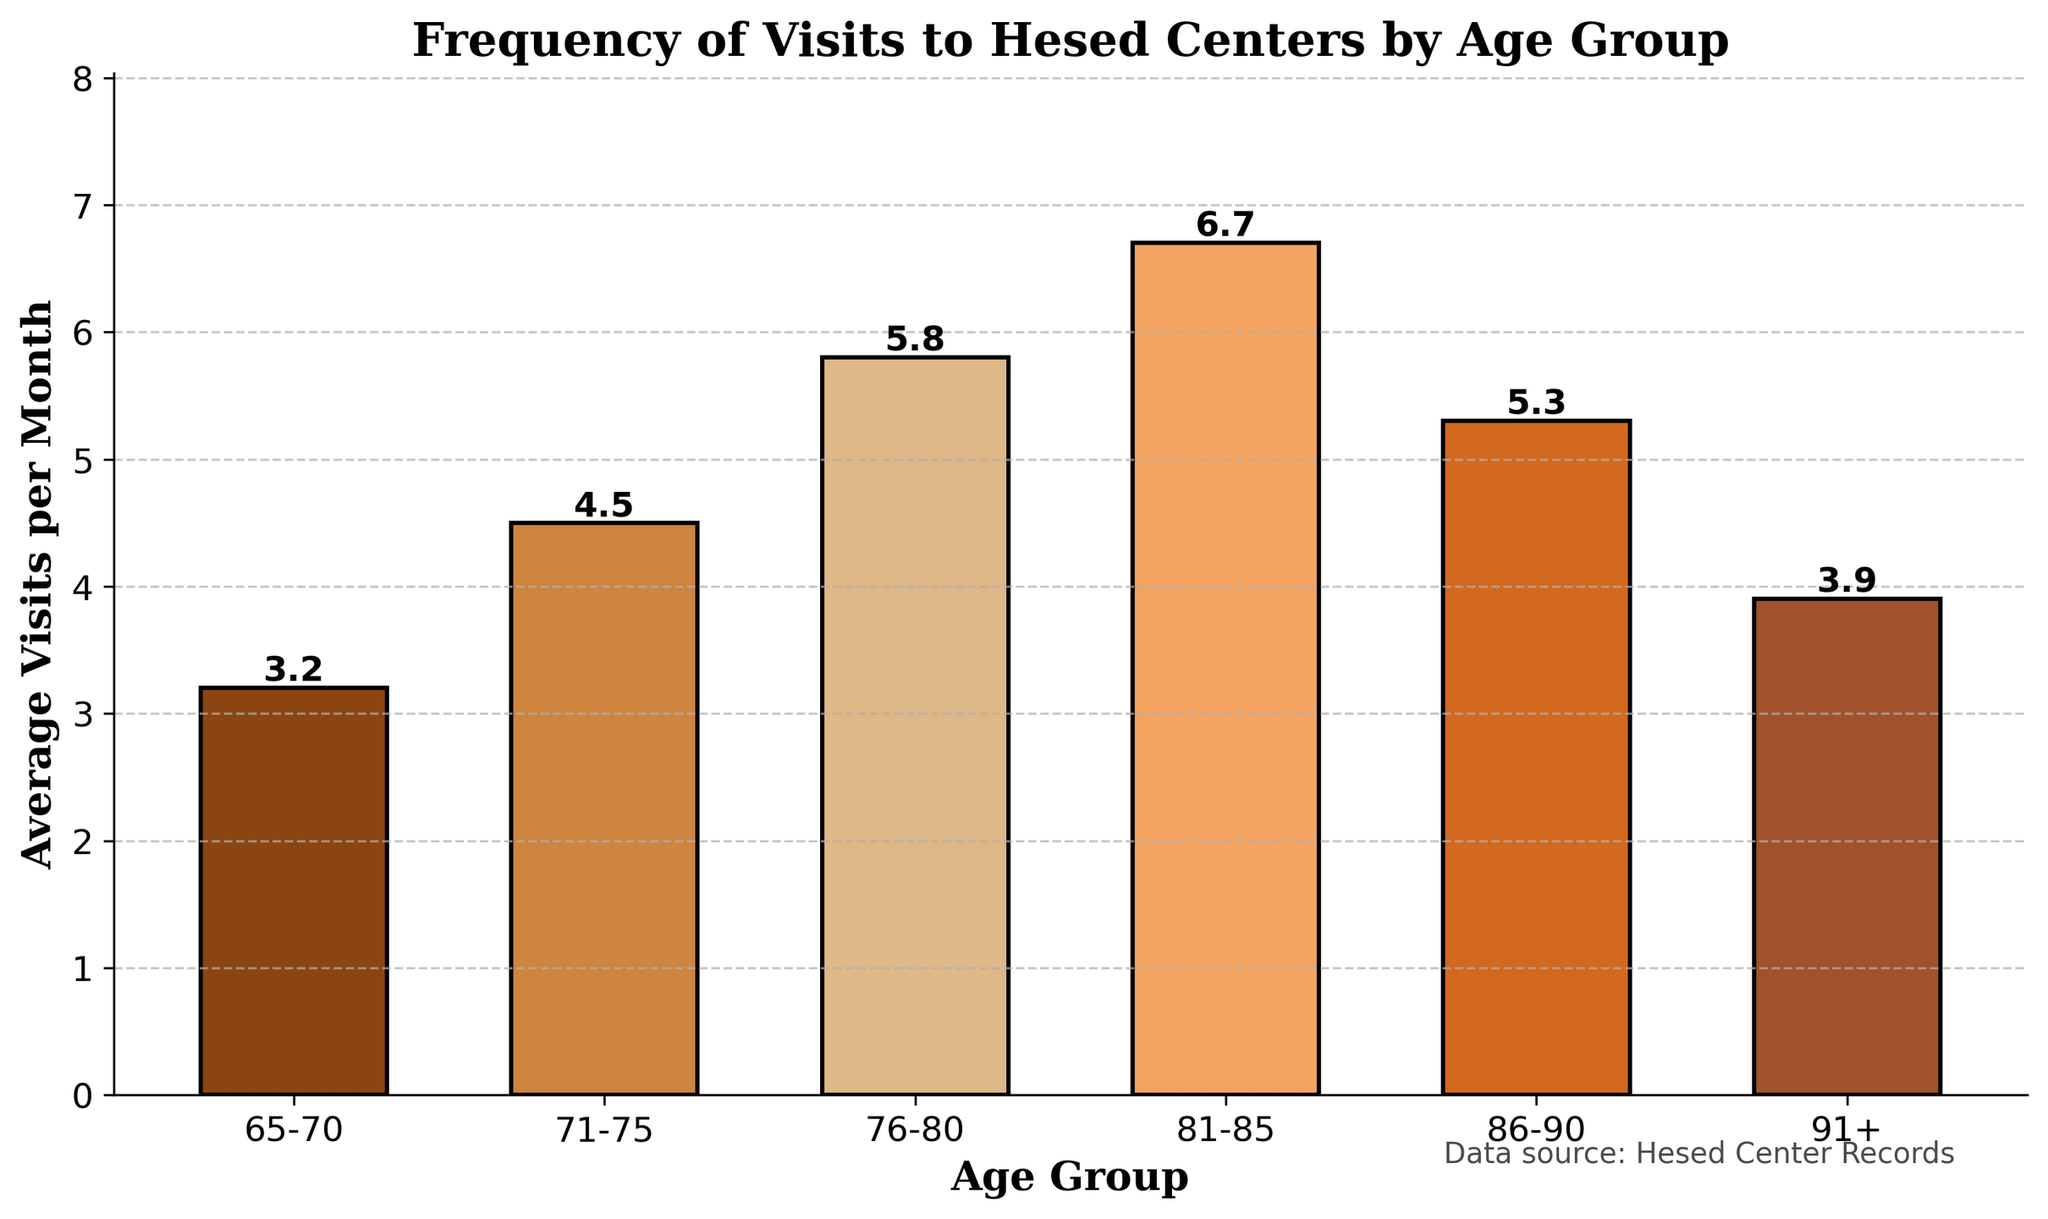What age group has the highest average visits per month? The age group with the highest bar represents the group with the most visits. By looking at the figure, the 81-85 age group has the tallest bar.
Answer: 81-85 How much is the difference in average visits per month between the 76-80 and 91+ age groups? Look at the heights of the bars for these age groups and subtract the shorter one from the taller one. The 76-80 age group has 5.8 visits, and the 91+ age group has 3.9 visits. The difference is 5.8 - 3.9.
Answer: 1.9 What is the total average visits per month for all age groups combined? Add the average visits per month of all the age groups together. The values are 3.2, 4.5, 5.8, 6.7, 5.3, and 3.9. The sum is 3.2 + 4.5 + 5.8 + 6.7 + 5.3 + 3.9.
Answer: 29.4 Which age group has a greater average visits per month: 71-75 or 86-90? Compare the heights of the bars for the 71-75 and 86-90 age groups. The 71-75 age group has 4.5 visits, while the 86-90 age group has 5.3 visits.
Answer: 86-90 What is the range of average visits per month among all age groups? The range is found by subtracting the smallest value from the largest value. The highest value is 6.7 (81-85 age group) and the lowest is 3.2 (65-70 age group). The range is 6.7 - 3.2.
Answer: 3.5 What percentage increase in average visits per month is observed from the 65-70 age group to the 81-85 age group? First, find the difference in average visits between these two groups, which is 6.7 - 3.2 = 3.5. Then calculate the percentage increase by dividing this difference by the initial number and multiplying by 100. So, (3.5 / 3.2) * 100.
Answer: 109.4% Between which consecutive age groups is there the largest increase in average visits per month? Calculate the increase in visits between each consecutive age group and find the maximum. The increases are: 
65-70 to 71-75: 4.5 - 3.2 = 1.3, 
71-75 to 76-80: 5.8 - 4.5 = 1.3, 
76-80 to 81-85: 6.7 - 5.8 = 0.9, 
81-85 to 86-90: 5.3 - 6.7 = -1.4, 
86-90 to 91+: 3.9 - 5.3 = -1.4. 
The largest increase is from 65-70 to 71-75 and from 71-75 to 76-80.
Answer: 65-70 to 71-75 and 71-75 to 76-80 Which age group has a lower average visits per month compared to the 76-80 age group but higher than the 65-70 age group? Identify an age group with an average number of visits that fits between 5.8 (76-80) and 3.2 (65-70). The 71-75 age group has 4.5 visits, which fits this criteria.
Answer: 71-75 